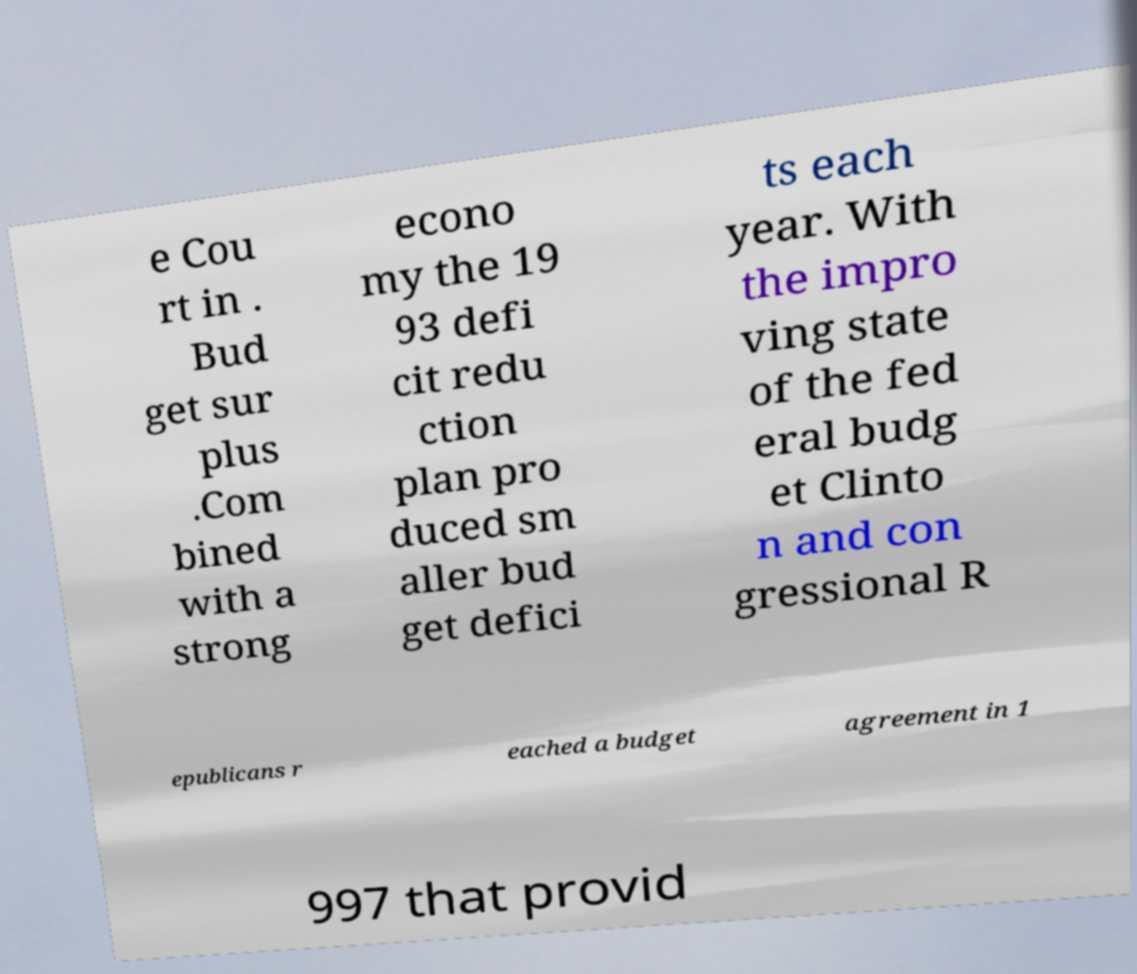Can you read and provide the text displayed in the image?This photo seems to have some interesting text. Can you extract and type it out for me? e Cou rt in . Bud get sur plus .Com bined with a strong econo my the 19 93 defi cit redu ction plan pro duced sm aller bud get defici ts each year. With the impro ving state of the fed eral budg et Clinto n and con gressional R epublicans r eached a budget agreement in 1 997 that provid 